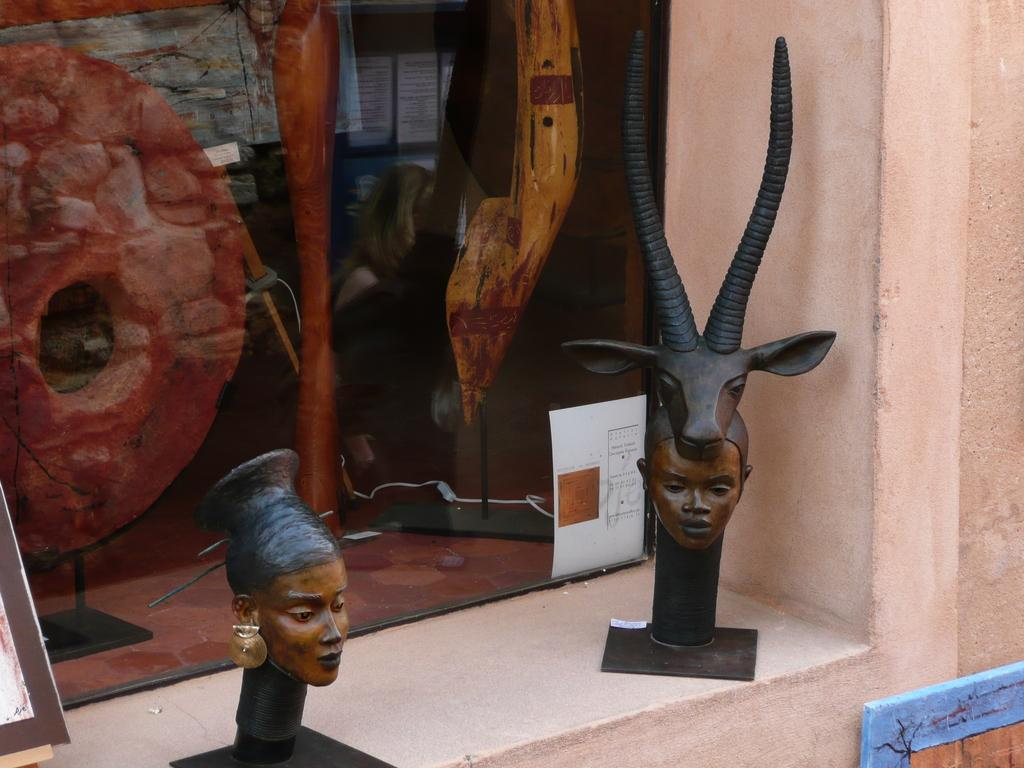What can be seen on the wall in the image? There are two sculptures on the wall. Is there anything else attached to the wall besides the sculptures? Yes, there is a glass with a paper attached to it at the back of the sculptures. What can be seen in the bottom right corner of the image? There is a board in the bottom right corner of the image. Is there a volcano erupting in the image? No, there is no volcano present in the image. How does the artist get the attention of the viewers in the image? The image does not show any specific techniques used by the artist to get the attention of the viewers. 